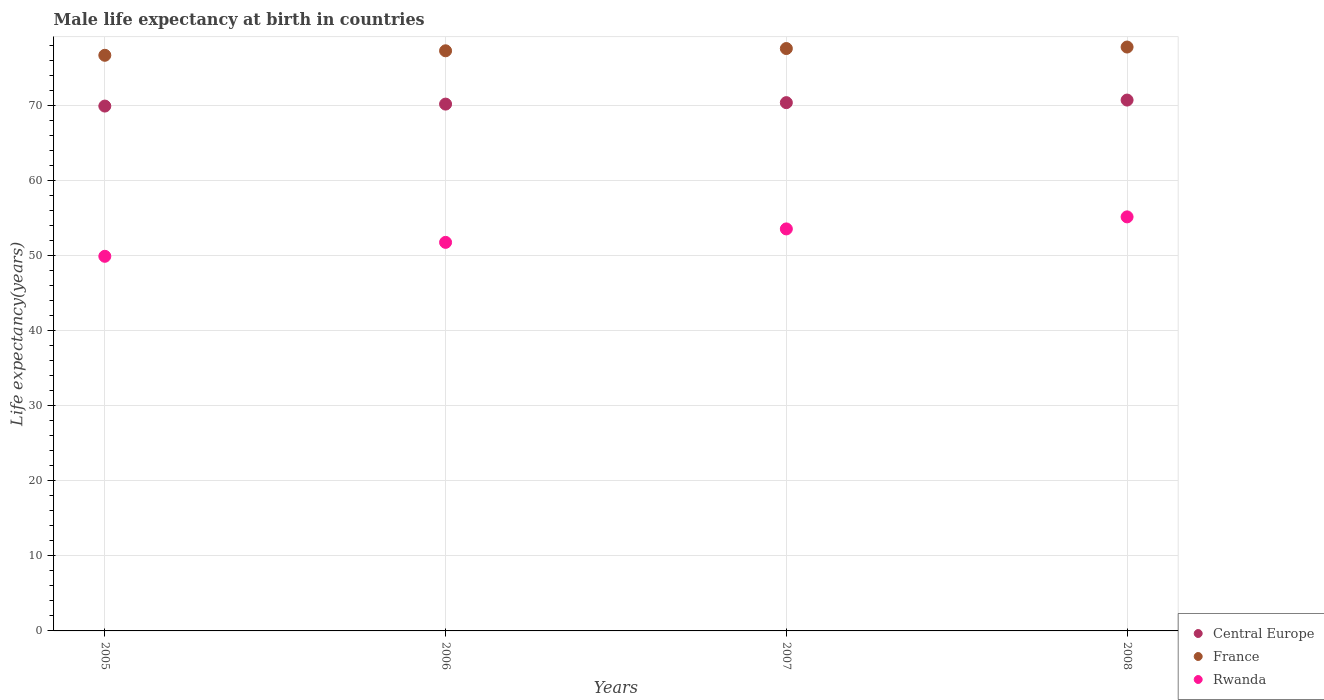Is the number of dotlines equal to the number of legend labels?
Your answer should be compact. Yes. What is the male life expectancy at birth in Rwanda in 2005?
Your answer should be very brief. 49.92. Across all years, what is the maximum male life expectancy at birth in Rwanda?
Give a very brief answer. 55.17. Across all years, what is the minimum male life expectancy at birth in Central Europe?
Make the answer very short. 69.93. What is the total male life expectancy at birth in France in the graph?
Give a very brief answer. 309.4. What is the difference between the male life expectancy at birth in Rwanda in 2007 and that in 2008?
Your answer should be compact. -1.6. What is the difference between the male life expectancy at birth in Rwanda in 2006 and the male life expectancy at birth in Central Europe in 2005?
Provide a short and direct response. -18.16. What is the average male life expectancy at birth in Rwanda per year?
Your response must be concise. 52.61. In the year 2008, what is the difference between the male life expectancy at birth in France and male life expectancy at birth in Central Europe?
Your answer should be very brief. 7.07. In how many years, is the male life expectancy at birth in Rwanda greater than 14 years?
Offer a terse response. 4. What is the ratio of the male life expectancy at birth in France in 2006 to that in 2008?
Your answer should be very brief. 0.99. Is the difference between the male life expectancy at birth in France in 2005 and 2008 greater than the difference between the male life expectancy at birth in Central Europe in 2005 and 2008?
Make the answer very short. No. What is the difference between the highest and the second highest male life expectancy at birth in Central Europe?
Ensure brevity in your answer.  0.34. What is the difference between the highest and the lowest male life expectancy at birth in France?
Ensure brevity in your answer.  1.1. Is the sum of the male life expectancy at birth in Rwanda in 2005 and 2008 greater than the maximum male life expectancy at birth in Central Europe across all years?
Offer a very short reply. Yes. Does the male life expectancy at birth in France monotonically increase over the years?
Make the answer very short. Yes. Is the male life expectancy at birth in France strictly greater than the male life expectancy at birth in Rwanda over the years?
Keep it short and to the point. Yes. How many years are there in the graph?
Provide a succinct answer. 4. Does the graph contain any zero values?
Give a very brief answer. No. Where does the legend appear in the graph?
Your answer should be very brief. Bottom right. What is the title of the graph?
Give a very brief answer. Male life expectancy at birth in countries. What is the label or title of the X-axis?
Offer a very short reply. Years. What is the label or title of the Y-axis?
Offer a terse response. Life expectancy(years). What is the Life expectancy(years) in Central Europe in 2005?
Your response must be concise. 69.93. What is the Life expectancy(years) in France in 2005?
Your answer should be very brief. 76.7. What is the Life expectancy(years) in Rwanda in 2005?
Your answer should be very brief. 49.92. What is the Life expectancy(years) of Central Europe in 2006?
Make the answer very short. 70.2. What is the Life expectancy(years) in France in 2006?
Keep it short and to the point. 77.3. What is the Life expectancy(years) of Rwanda in 2006?
Keep it short and to the point. 51.77. What is the Life expectancy(years) in Central Europe in 2007?
Offer a very short reply. 70.39. What is the Life expectancy(years) in France in 2007?
Keep it short and to the point. 77.6. What is the Life expectancy(years) in Rwanda in 2007?
Give a very brief answer. 53.57. What is the Life expectancy(years) in Central Europe in 2008?
Offer a terse response. 70.73. What is the Life expectancy(years) of France in 2008?
Provide a succinct answer. 77.8. What is the Life expectancy(years) of Rwanda in 2008?
Your answer should be very brief. 55.17. Across all years, what is the maximum Life expectancy(years) of Central Europe?
Your answer should be compact. 70.73. Across all years, what is the maximum Life expectancy(years) of France?
Your answer should be compact. 77.8. Across all years, what is the maximum Life expectancy(years) of Rwanda?
Make the answer very short. 55.17. Across all years, what is the minimum Life expectancy(years) of Central Europe?
Offer a terse response. 69.93. Across all years, what is the minimum Life expectancy(years) in France?
Give a very brief answer. 76.7. Across all years, what is the minimum Life expectancy(years) in Rwanda?
Offer a very short reply. 49.92. What is the total Life expectancy(years) of Central Europe in the graph?
Provide a succinct answer. 281.26. What is the total Life expectancy(years) in France in the graph?
Keep it short and to the point. 309.4. What is the total Life expectancy(years) of Rwanda in the graph?
Your response must be concise. 210.42. What is the difference between the Life expectancy(years) of Central Europe in 2005 and that in 2006?
Provide a succinct answer. -0.26. What is the difference between the Life expectancy(years) of France in 2005 and that in 2006?
Give a very brief answer. -0.6. What is the difference between the Life expectancy(years) of Rwanda in 2005 and that in 2006?
Make the answer very short. -1.86. What is the difference between the Life expectancy(years) of Central Europe in 2005 and that in 2007?
Provide a short and direct response. -0.46. What is the difference between the Life expectancy(years) of France in 2005 and that in 2007?
Give a very brief answer. -0.9. What is the difference between the Life expectancy(years) in Rwanda in 2005 and that in 2007?
Keep it short and to the point. -3.65. What is the difference between the Life expectancy(years) in Central Europe in 2005 and that in 2008?
Keep it short and to the point. -0.8. What is the difference between the Life expectancy(years) in France in 2005 and that in 2008?
Provide a succinct answer. -1.1. What is the difference between the Life expectancy(years) in Rwanda in 2005 and that in 2008?
Ensure brevity in your answer.  -5.25. What is the difference between the Life expectancy(years) in Central Europe in 2006 and that in 2007?
Keep it short and to the point. -0.2. What is the difference between the Life expectancy(years) of Rwanda in 2006 and that in 2007?
Make the answer very short. -1.79. What is the difference between the Life expectancy(years) in Central Europe in 2006 and that in 2008?
Your answer should be compact. -0.54. What is the difference between the Life expectancy(years) of France in 2006 and that in 2008?
Provide a succinct answer. -0.5. What is the difference between the Life expectancy(years) of Rwanda in 2006 and that in 2008?
Your answer should be very brief. -3.4. What is the difference between the Life expectancy(years) of Central Europe in 2007 and that in 2008?
Your response must be concise. -0.34. What is the difference between the Life expectancy(years) in France in 2007 and that in 2008?
Your response must be concise. -0.2. What is the difference between the Life expectancy(years) in Rwanda in 2007 and that in 2008?
Give a very brief answer. -1.6. What is the difference between the Life expectancy(years) of Central Europe in 2005 and the Life expectancy(years) of France in 2006?
Give a very brief answer. -7.37. What is the difference between the Life expectancy(years) in Central Europe in 2005 and the Life expectancy(years) in Rwanda in 2006?
Give a very brief answer. 18.16. What is the difference between the Life expectancy(years) in France in 2005 and the Life expectancy(years) in Rwanda in 2006?
Your answer should be compact. 24.93. What is the difference between the Life expectancy(years) of Central Europe in 2005 and the Life expectancy(years) of France in 2007?
Provide a short and direct response. -7.67. What is the difference between the Life expectancy(years) of Central Europe in 2005 and the Life expectancy(years) of Rwanda in 2007?
Your answer should be compact. 16.37. What is the difference between the Life expectancy(years) in France in 2005 and the Life expectancy(years) in Rwanda in 2007?
Give a very brief answer. 23.13. What is the difference between the Life expectancy(years) of Central Europe in 2005 and the Life expectancy(years) of France in 2008?
Provide a succinct answer. -7.87. What is the difference between the Life expectancy(years) of Central Europe in 2005 and the Life expectancy(years) of Rwanda in 2008?
Offer a terse response. 14.77. What is the difference between the Life expectancy(years) of France in 2005 and the Life expectancy(years) of Rwanda in 2008?
Provide a succinct answer. 21.53. What is the difference between the Life expectancy(years) of Central Europe in 2006 and the Life expectancy(years) of France in 2007?
Your answer should be compact. -7.4. What is the difference between the Life expectancy(years) in Central Europe in 2006 and the Life expectancy(years) in Rwanda in 2007?
Offer a terse response. 16.63. What is the difference between the Life expectancy(years) of France in 2006 and the Life expectancy(years) of Rwanda in 2007?
Keep it short and to the point. 23.73. What is the difference between the Life expectancy(years) of Central Europe in 2006 and the Life expectancy(years) of France in 2008?
Keep it short and to the point. -7.6. What is the difference between the Life expectancy(years) in Central Europe in 2006 and the Life expectancy(years) in Rwanda in 2008?
Keep it short and to the point. 15.03. What is the difference between the Life expectancy(years) of France in 2006 and the Life expectancy(years) of Rwanda in 2008?
Make the answer very short. 22.13. What is the difference between the Life expectancy(years) of Central Europe in 2007 and the Life expectancy(years) of France in 2008?
Provide a succinct answer. -7.41. What is the difference between the Life expectancy(years) in Central Europe in 2007 and the Life expectancy(years) in Rwanda in 2008?
Your response must be concise. 15.22. What is the difference between the Life expectancy(years) of France in 2007 and the Life expectancy(years) of Rwanda in 2008?
Offer a terse response. 22.43. What is the average Life expectancy(years) of Central Europe per year?
Ensure brevity in your answer.  70.31. What is the average Life expectancy(years) of France per year?
Keep it short and to the point. 77.35. What is the average Life expectancy(years) in Rwanda per year?
Your answer should be very brief. 52.61. In the year 2005, what is the difference between the Life expectancy(years) of Central Europe and Life expectancy(years) of France?
Make the answer very short. -6.77. In the year 2005, what is the difference between the Life expectancy(years) of Central Europe and Life expectancy(years) of Rwanda?
Keep it short and to the point. 20.02. In the year 2005, what is the difference between the Life expectancy(years) of France and Life expectancy(years) of Rwanda?
Your answer should be compact. 26.78. In the year 2006, what is the difference between the Life expectancy(years) of Central Europe and Life expectancy(years) of France?
Make the answer very short. -7.1. In the year 2006, what is the difference between the Life expectancy(years) in Central Europe and Life expectancy(years) in Rwanda?
Offer a terse response. 18.42. In the year 2006, what is the difference between the Life expectancy(years) in France and Life expectancy(years) in Rwanda?
Your answer should be compact. 25.53. In the year 2007, what is the difference between the Life expectancy(years) of Central Europe and Life expectancy(years) of France?
Keep it short and to the point. -7.21. In the year 2007, what is the difference between the Life expectancy(years) in Central Europe and Life expectancy(years) in Rwanda?
Provide a short and direct response. 16.82. In the year 2007, what is the difference between the Life expectancy(years) in France and Life expectancy(years) in Rwanda?
Your answer should be very brief. 24.03. In the year 2008, what is the difference between the Life expectancy(years) of Central Europe and Life expectancy(years) of France?
Provide a short and direct response. -7.07. In the year 2008, what is the difference between the Life expectancy(years) of Central Europe and Life expectancy(years) of Rwanda?
Offer a terse response. 15.56. In the year 2008, what is the difference between the Life expectancy(years) in France and Life expectancy(years) in Rwanda?
Your answer should be very brief. 22.63. What is the ratio of the Life expectancy(years) of Central Europe in 2005 to that in 2006?
Provide a short and direct response. 1. What is the ratio of the Life expectancy(years) of Rwanda in 2005 to that in 2006?
Your answer should be compact. 0.96. What is the ratio of the Life expectancy(years) in France in 2005 to that in 2007?
Make the answer very short. 0.99. What is the ratio of the Life expectancy(years) of Rwanda in 2005 to that in 2007?
Your response must be concise. 0.93. What is the ratio of the Life expectancy(years) of Central Europe in 2005 to that in 2008?
Provide a succinct answer. 0.99. What is the ratio of the Life expectancy(years) in France in 2005 to that in 2008?
Provide a short and direct response. 0.99. What is the ratio of the Life expectancy(years) in Rwanda in 2005 to that in 2008?
Your answer should be compact. 0.9. What is the ratio of the Life expectancy(years) of Rwanda in 2006 to that in 2007?
Keep it short and to the point. 0.97. What is the ratio of the Life expectancy(years) of Central Europe in 2006 to that in 2008?
Your response must be concise. 0.99. What is the ratio of the Life expectancy(years) in Rwanda in 2006 to that in 2008?
Your response must be concise. 0.94. What is the ratio of the Life expectancy(years) of Central Europe in 2007 to that in 2008?
Ensure brevity in your answer.  1. What is the ratio of the Life expectancy(years) in France in 2007 to that in 2008?
Offer a terse response. 1. What is the ratio of the Life expectancy(years) of Rwanda in 2007 to that in 2008?
Ensure brevity in your answer.  0.97. What is the difference between the highest and the second highest Life expectancy(years) in Central Europe?
Ensure brevity in your answer.  0.34. What is the difference between the highest and the second highest Life expectancy(years) in France?
Provide a short and direct response. 0.2. What is the difference between the highest and the second highest Life expectancy(years) of Rwanda?
Keep it short and to the point. 1.6. What is the difference between the highest and the lowest Life expectancy(years) in Central Europe?
Your answer should be very brief. 0.8. What is the difference between the highest and the lowest Life expectancy(years) of Rwanda?
Your response must be concise. 5.25. 